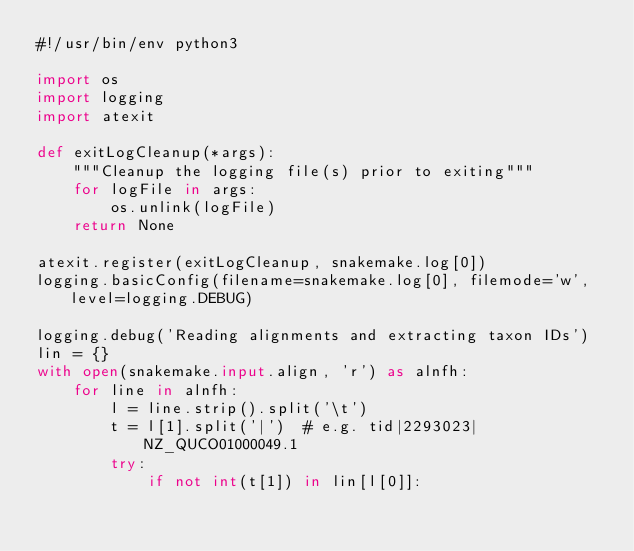<code> <loc_0><loc_0><loc_500><loc_500><_Python_>#!/usr/bin/env python3

import os
import logging
import atexit

def exitLogCleanup(*args):
    """Cleanup the logging file(s) prior to exiting"""
    for logFile in args:
        os.unlink(logFile)
    return None

atexit.register(exitLogCleanup, snakemake.log[0])
logging.basicConfig(filename=snakemake.log[0], filemode='w', level=logging.DEBUG)

logging.debug('Reading alignments and extracting taxon IDs')
lin = {}
with open(snakemake.input.align, 'r') as alnfh:
    for line in alnfh:
        l = line.strip().split('\t')
        t = l[1].split('|')  # e.g. tid|2293023|NZ_QUCO01000049.1
        try:
            if not int(t[1]) in lin[l[0]]:</code> 